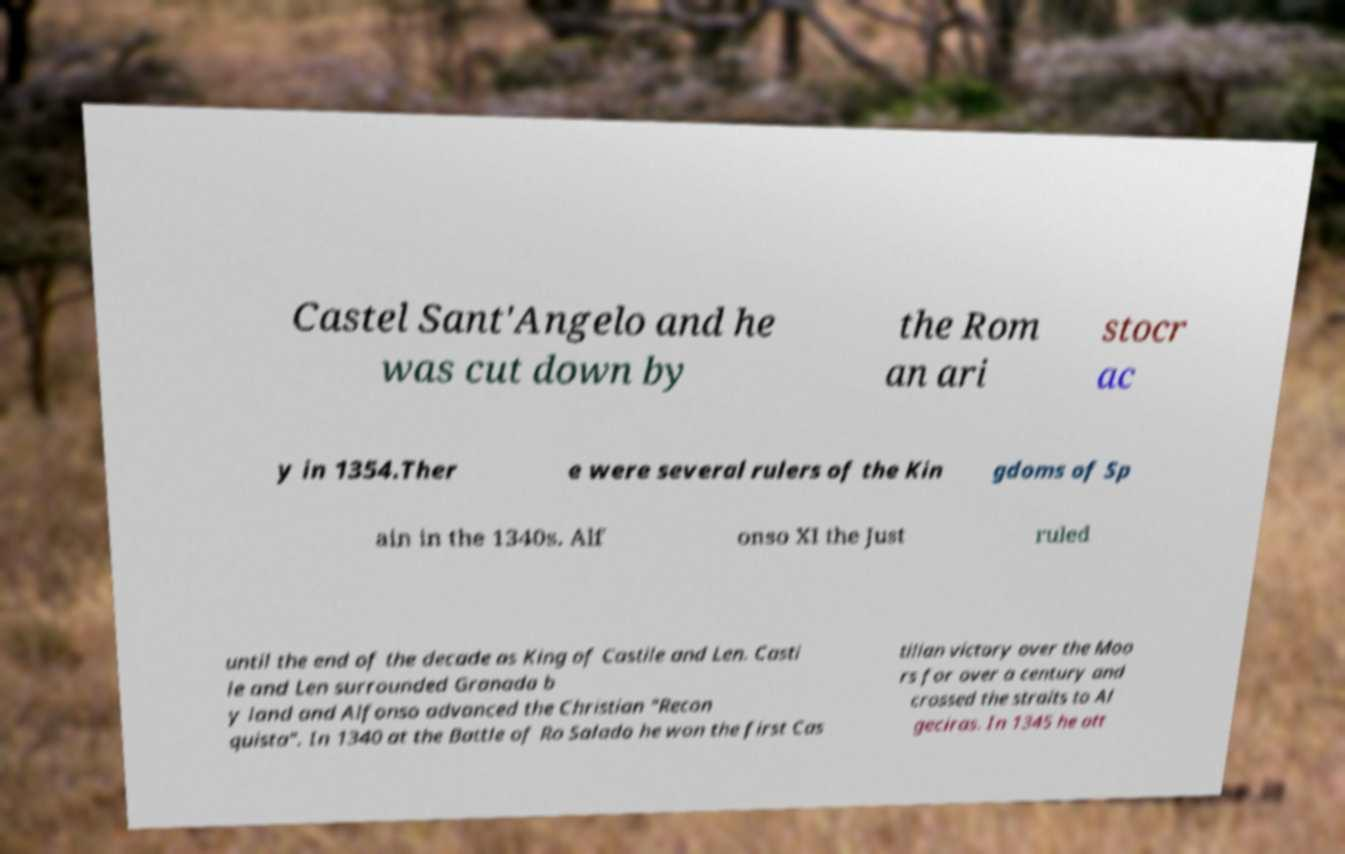Please identify and transcribe the text found in this image. Castel Sant'Angelo and he was cut down by the Rom an ari stocr ac y in 1354.Ther e were several rulers of the Kin gdoms of Sp ain in the 1340s. Alf onso XI the Just ruled until the end of the decade as King of Castile and Len. Casti le and Len surrounded Granada b y land and Alfonso advanced the Christian "Recon quista". In 1340 at the Battle of Ro Salado he won the first Cas tilian victory over the Moo rs for over a century and crossed the straits to Al geciras. In 1345 he att 